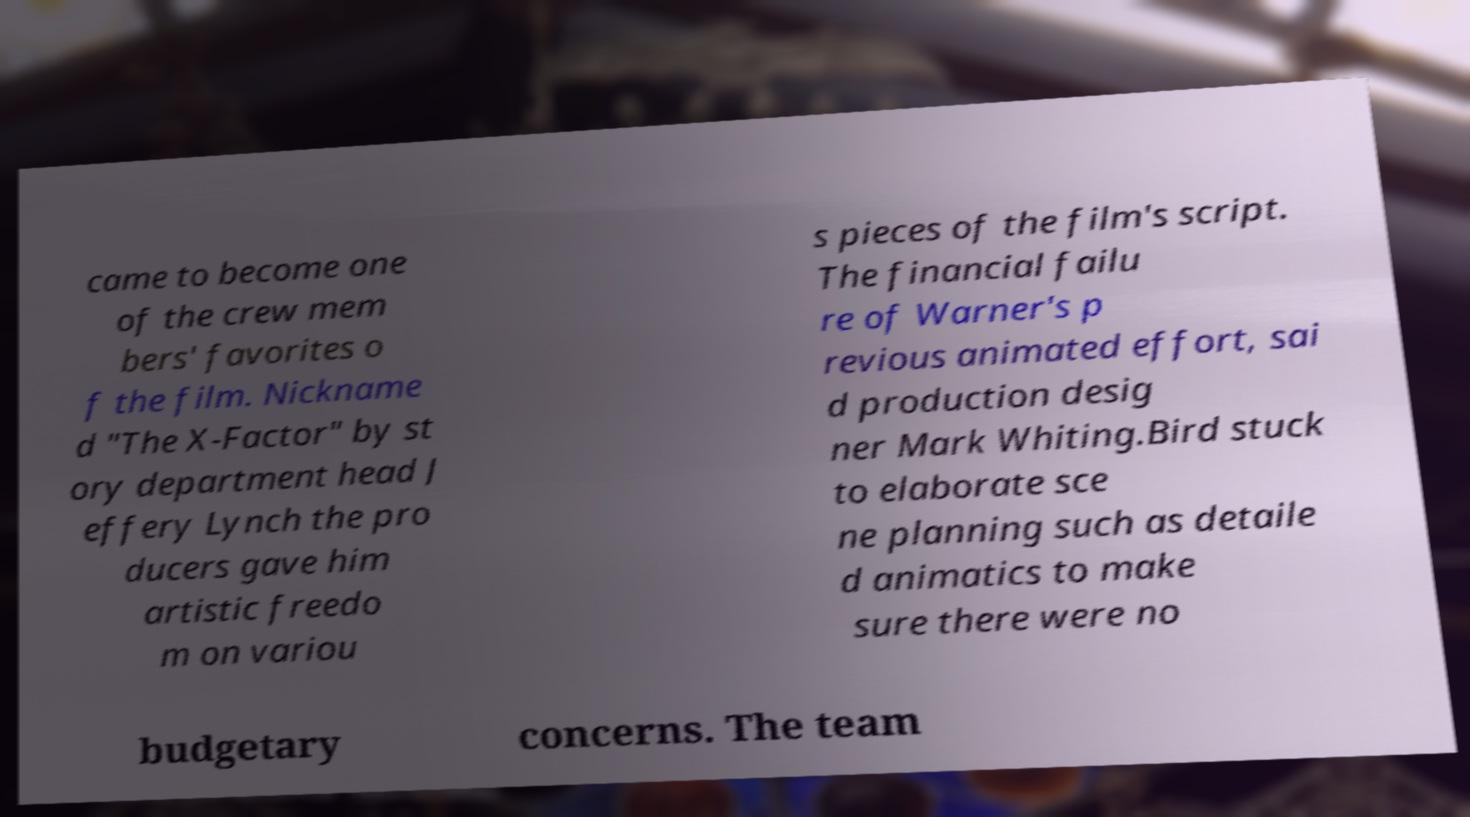Could you assist in decoding the text presented in this image and type it out clearly? came to become one of the crew mem bers' favorites o f the film. Nickname d "The X-Factor" by st ory department head J effery Lynch the pro ducers gave him artistic freedo m on variou s pieces of the film's script. The financial failu re of Warner's p revious animated effort, sai d production desig ner Mark Whiting.Bird stuck to elaborate sce ne planning such as detaile d animatics to make sure there were no budgetary concerns. The team 